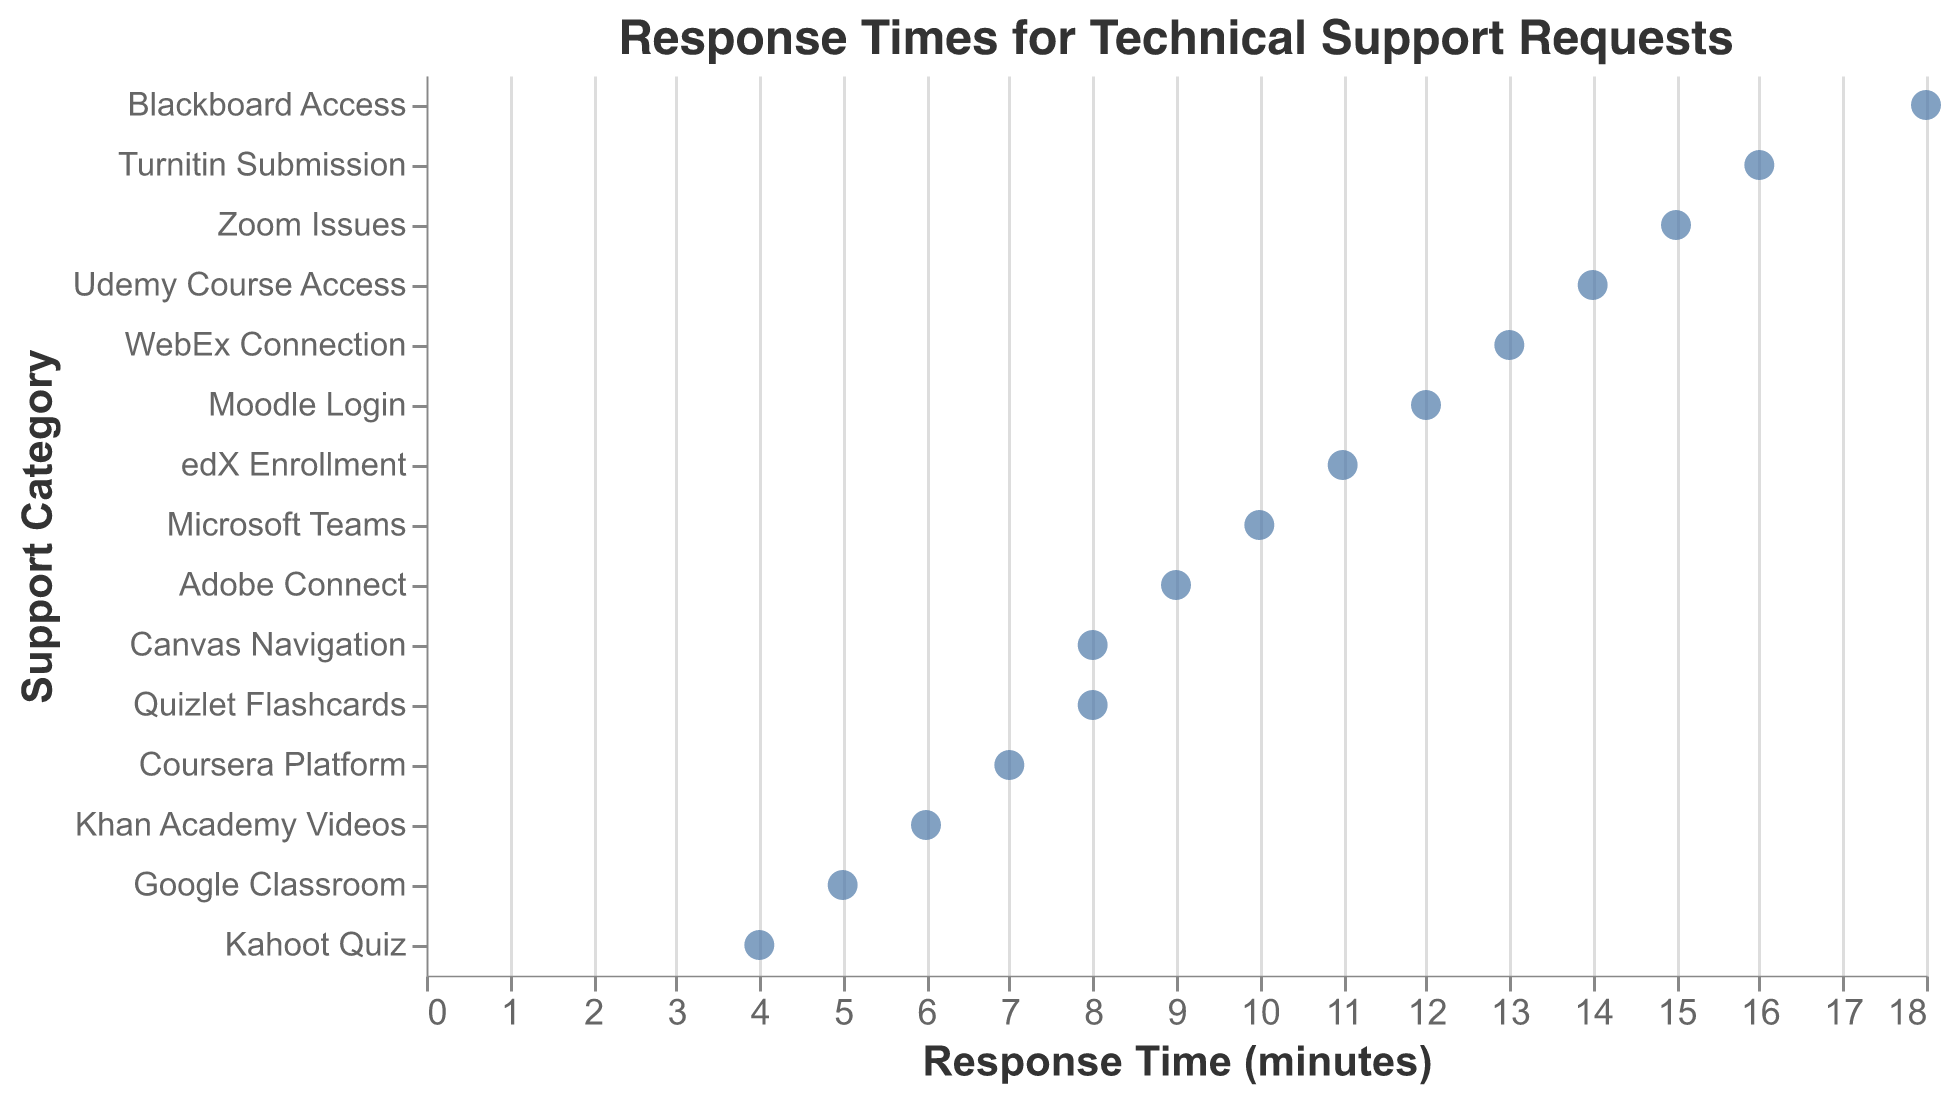What is the response time for Microsoft Teams? The strip plot shows the response times on the x-axis and the support categories on the y-axis. By locating Microsoft Teams on the y-axis and tracing it to the x-axis, we see the response time is shown as a point at 10.
Answer: 10 minutes Which support request category has the longest response time? By examining the strip plot, we identify the category that has the furthest point along the x-axis. This point corresponds to Blackboard Access.
Answer: Blackboard Access What is the difference in response times between Kahoot Quiz and Moodle Login requests? Kahoot Quiz has a response time of 4 minutes, and Moodle Login has a response time of 12 minutes. Subtracting these gives 12 - 4 = 8 minutes.
Answer: 8 minutes How many categories have a response time of more than 10 minutes? To find this, we look for data points on the plot that are positioned beyond 10 minutes on the x-axis. These categories are Zoom Issues, Blackboard Access, WebEx Connection, Udemy Course Access, and Turnitin Submission. Counting these, we get 5 categories.
Answer: 5 categories What is the median response time for all categories? Listing out the response times: 4, 5, 6, 7, 8, 8, 9, 10, 11, 12, 13, 14, 15, 16, 18; we find the middle value. The median is the 8th value in the ordered list, which is 10.
Answer: 10 minutes Which support category responds faster, Google Classroom or Canvas Navigation? Google Classroom shows a response time of 5 minutes, whereas Canvas Navigation shows 8 minutes. Comparing these, Google Classroom is faster.
Answer: Google Classroom What is the range of response times in this plot? The range is found by subtracting the minimum response time from the maximum. The minimum is 4 (Kahoot Quiz), and the maximum is 18 (Blackboard Access). Therefore, the range is 18 - 4 = 14 minutes.
Answer: 14 minutes Is there a category with the same response time as Quizlet Flashcards? If so, what is it? Quizlet Flashcards has a response time of 8 minutes. Looking for another category with the same value, we find Canvas Navigation also with a response time of 8 minutes.
Answer: Canvas Navigation What is the average response time for Udemy Course Access and Khan Academy Videos? Udemy Course Access has a response time of 14 minutes and Khan Academy Videos has 6 minutes. The average is calculated as (14 + 6) / 2 = 20 / 2 = 10 minutes.
Answer: 10 minutes 